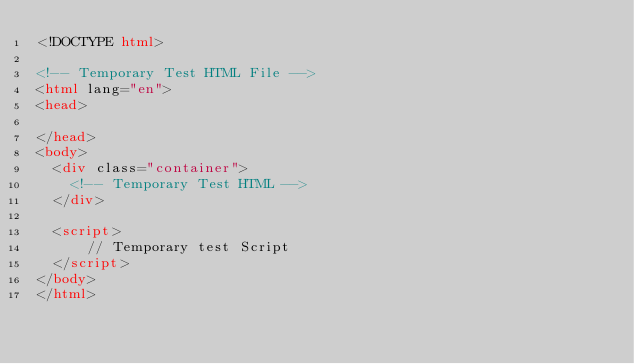<code> <loc_0><loc_0><loc_500><loc_500><_HTML_><!DOCTYPE html>

<!-- Temporary Test HTML File -->
<html lang="en">
<head>
  
</head>
<body>
  <div class="container">
    <!-- Temporary Test HTML -->
  </div>
 
  <script>
      // Temporary test Script
  </script>
</body>
</html></code> 